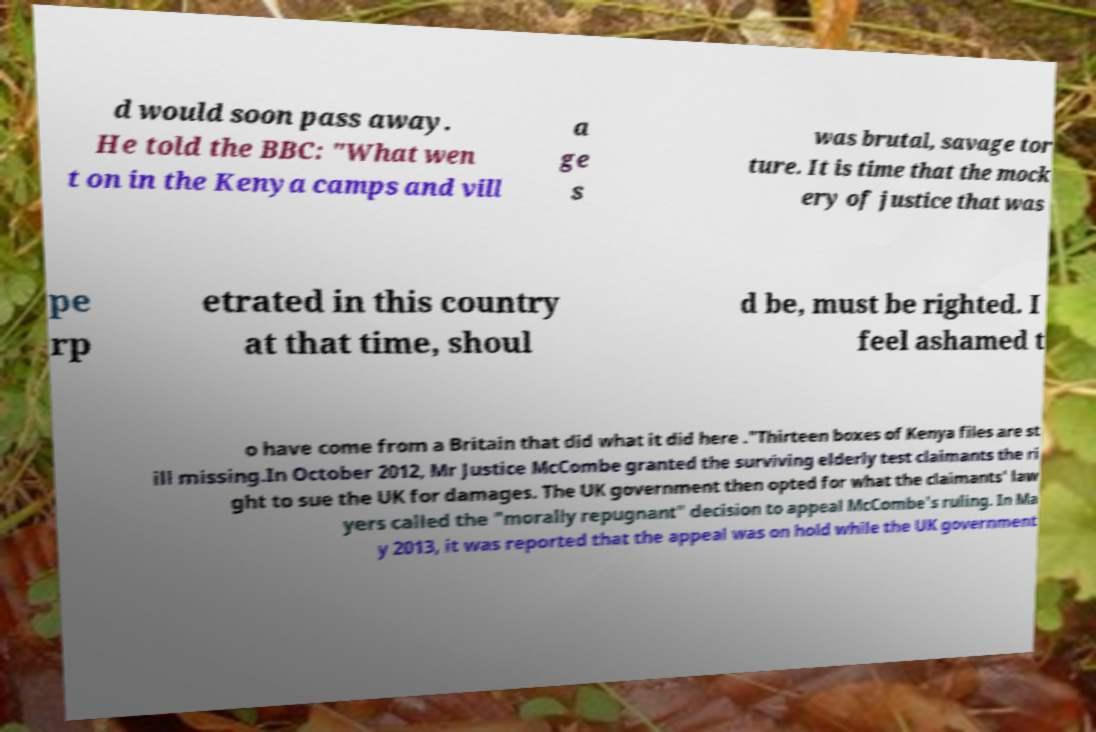Can you accurately transcribe the text from the provided image for me? d would soon pass away. He told the BBC: "What wen t on in the Kenya camps and vill a ge s was brutal, savage tor ture. It is time that the mock ery of justice that was pe rp etrated in this country at that time, shoul d be, must be righted. I feel ashamed t o have come from a Britain that did what it did here ."Thirteen boxes of Kenya files are st ill missing.In October 2012, Mr Justice McCombe granted the surviving elderly test claimants the ri ght to sue the UK for damages. The UK government then opted for what the claimants' law yers called the "morally repugnant" decision to appeal McCombe's ruling. In Ma y 2013, it was reported that the appeal was on hold while the UK government 